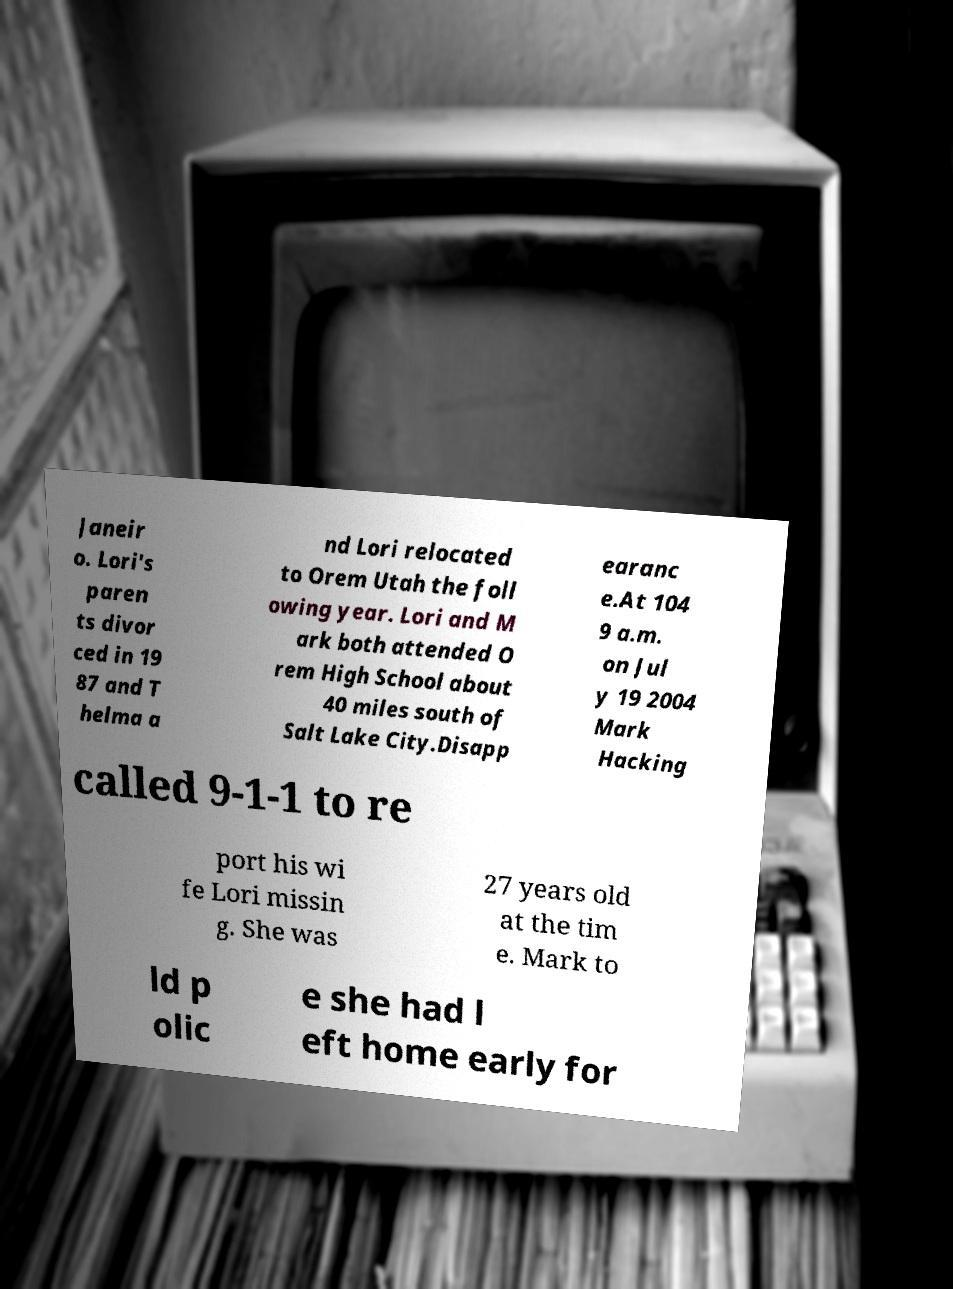For documentation purposes, I need the text within this image transcribed. Could you provide that? Janeir o. Lori's paren ts divor ced in 19 87 and T helma a nd Lori relocated to Orem Utah the foll owing year. Lori and M ark both attended O rem High School about 40 miles south of Salt Lake City.Disapp earanc e.At 104 9 a.m. on Jul y 19 2004 Mark Hacking called 9-1-1 to re port his wi fe Lori missin g. She was 27 years old at the tim e. Mark to ld p olic e she had l eft home early for 